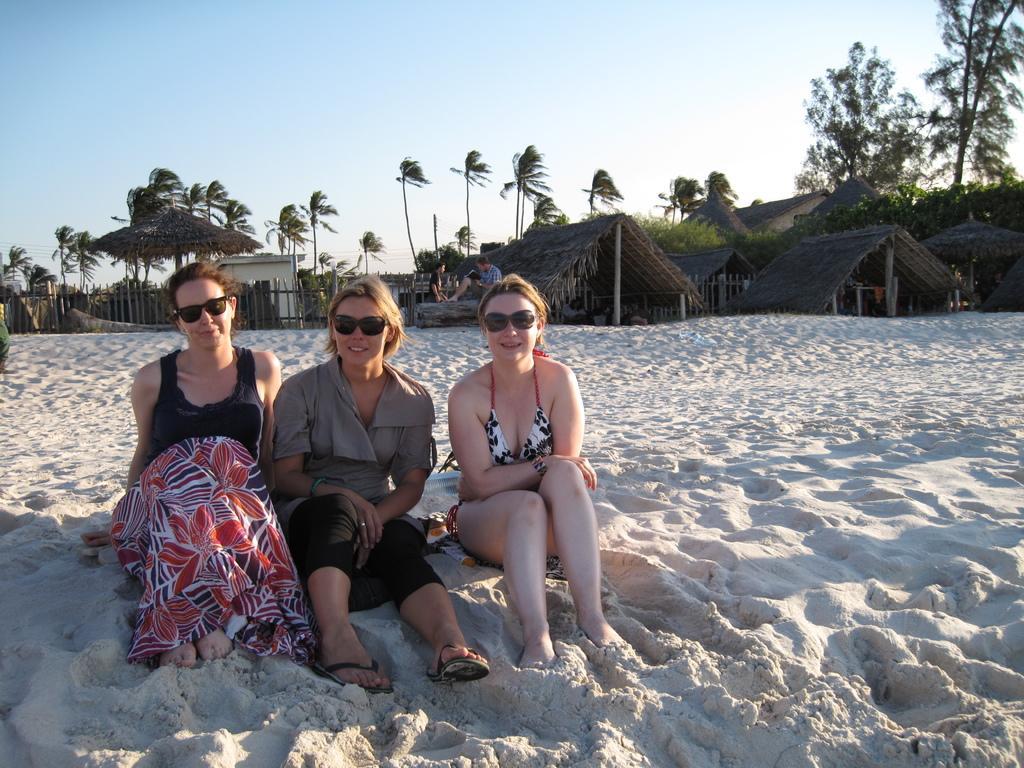In one or two sentences, can you explain what this image depicts? In this picture I can see women are sitting on the sand. These women are wearing black color shades. In the background I can see people, trees, beach huts and the sky. 